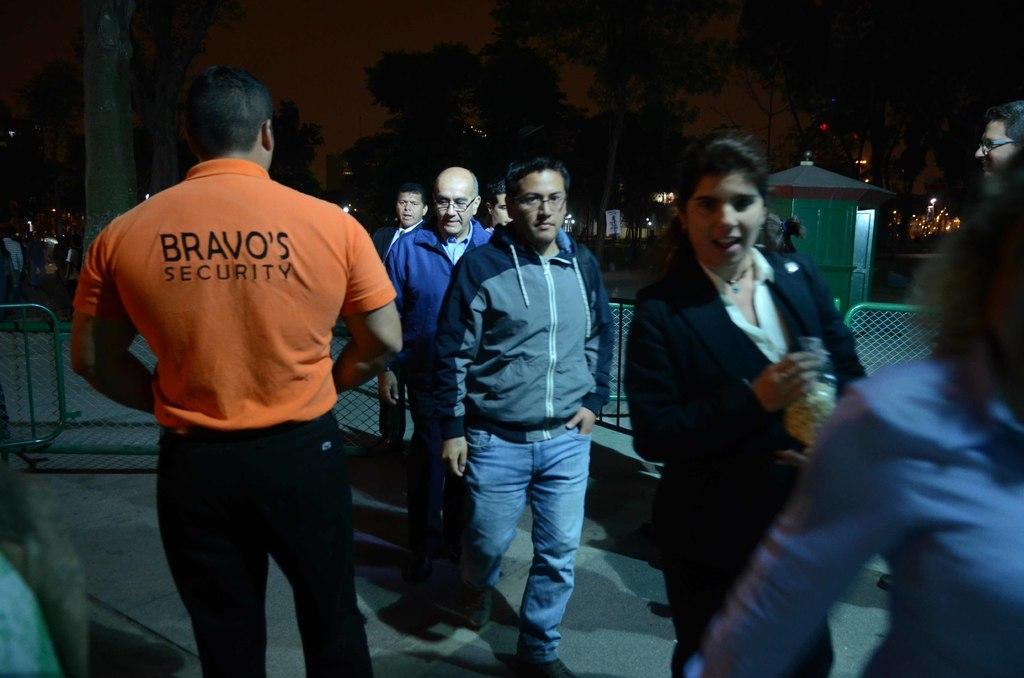Describe this image in one or two sentences. In the image there are few persons walking on the right side and on the left side there is security guard standing, this is clicked at night time, in the background there are trees and buildings. 